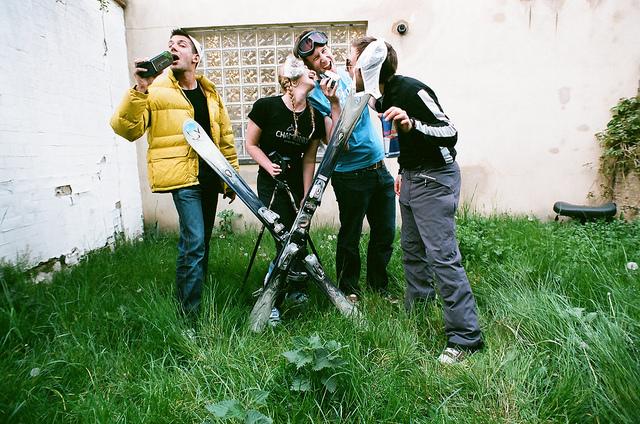How many people are wearing black?
Keep it brief. 3. How many people are there?
Short answer required. 4. What color is the grass?
Be succinct. Green. 